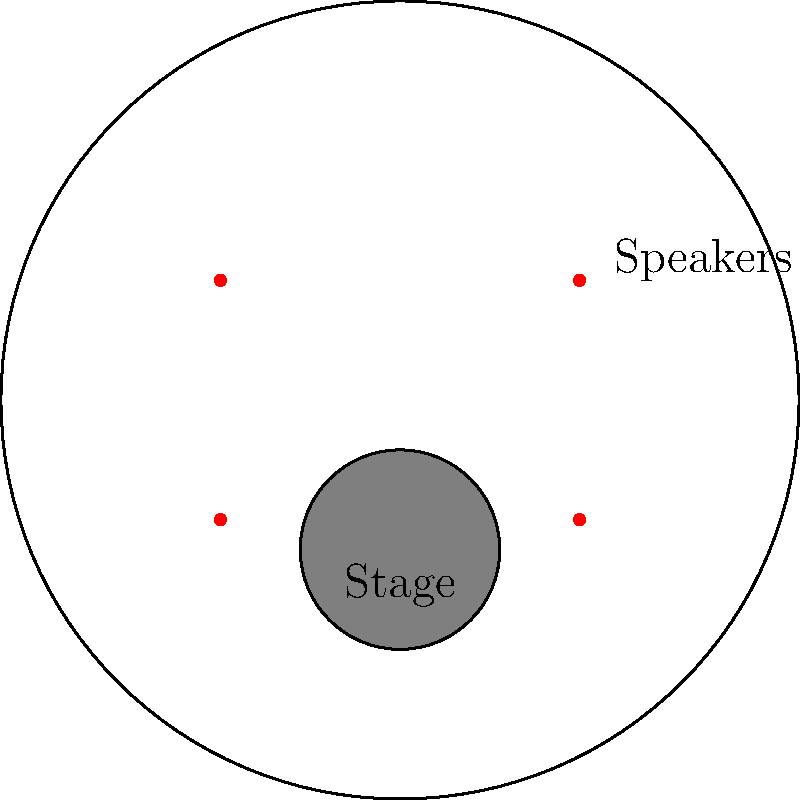As an aspiring rock band leader, you're planning your first big concert. The venue is circular, and you need to decide on speaker placement. Which arrangement would provide the most even sound distribution throughout the venue?

A) Four speakers at the corners of the stage
B) Two speakers at the front of the stage
C) Four speakers evenly spaced around the perimeter of the venue
D) One large central speaker above the stage To determine the optimal speaker placement for even sound distribution, let's consider the following steps:

1. Sound propagation: Sound waves travel outward from their source in a spherical pattern.

2. Coverage area: The goal is to ensure that sound reaches all areas of the venue with similar intensity.

3. Interference patterns: Multiple speakers can create interference patterns, which can lead to uneven sound distribution.

4. Distance from source: Sound intensity decreases with distance from the source according to the inverse square law: $I \propto \frac{1}{r^2}$, where $I$ is intensity and $r$ is distance.

5. Analyzing the options:
   A) Speakers at the corners of the stage would result in uneven coverage, with some areas receiving more intense sound than others.
   B) Two speakers at the front would not provide adequate coverage for the entire circular venue.
   D) A single central speaker would result in significant variations in sound intensity from front to back.
   C) Evenly spaced speakers around the perimeter would provide the most uniform coverage:
      - Each point in the venue would be relatively close to at least one speaker.
      - The overlapping coverage from multiple speakers would help create a more consistent sound level.
      - This arrangement minimizes the maximum distance between any point in the venue and the nearest speaker.

6. Professional practice: In real-world scenarios, sound engineers often use multiple speakers around the venue perimeter, sometimes supplemented with delay speakers, to achieve even coverage.

Therefore, option C (four speakers evenly spaced around the perimeter of the venue) would provide the most even sound distribution throughout the circular venue.
Answer: C) Four speakers evenly spaced around the perimeter of the venue 